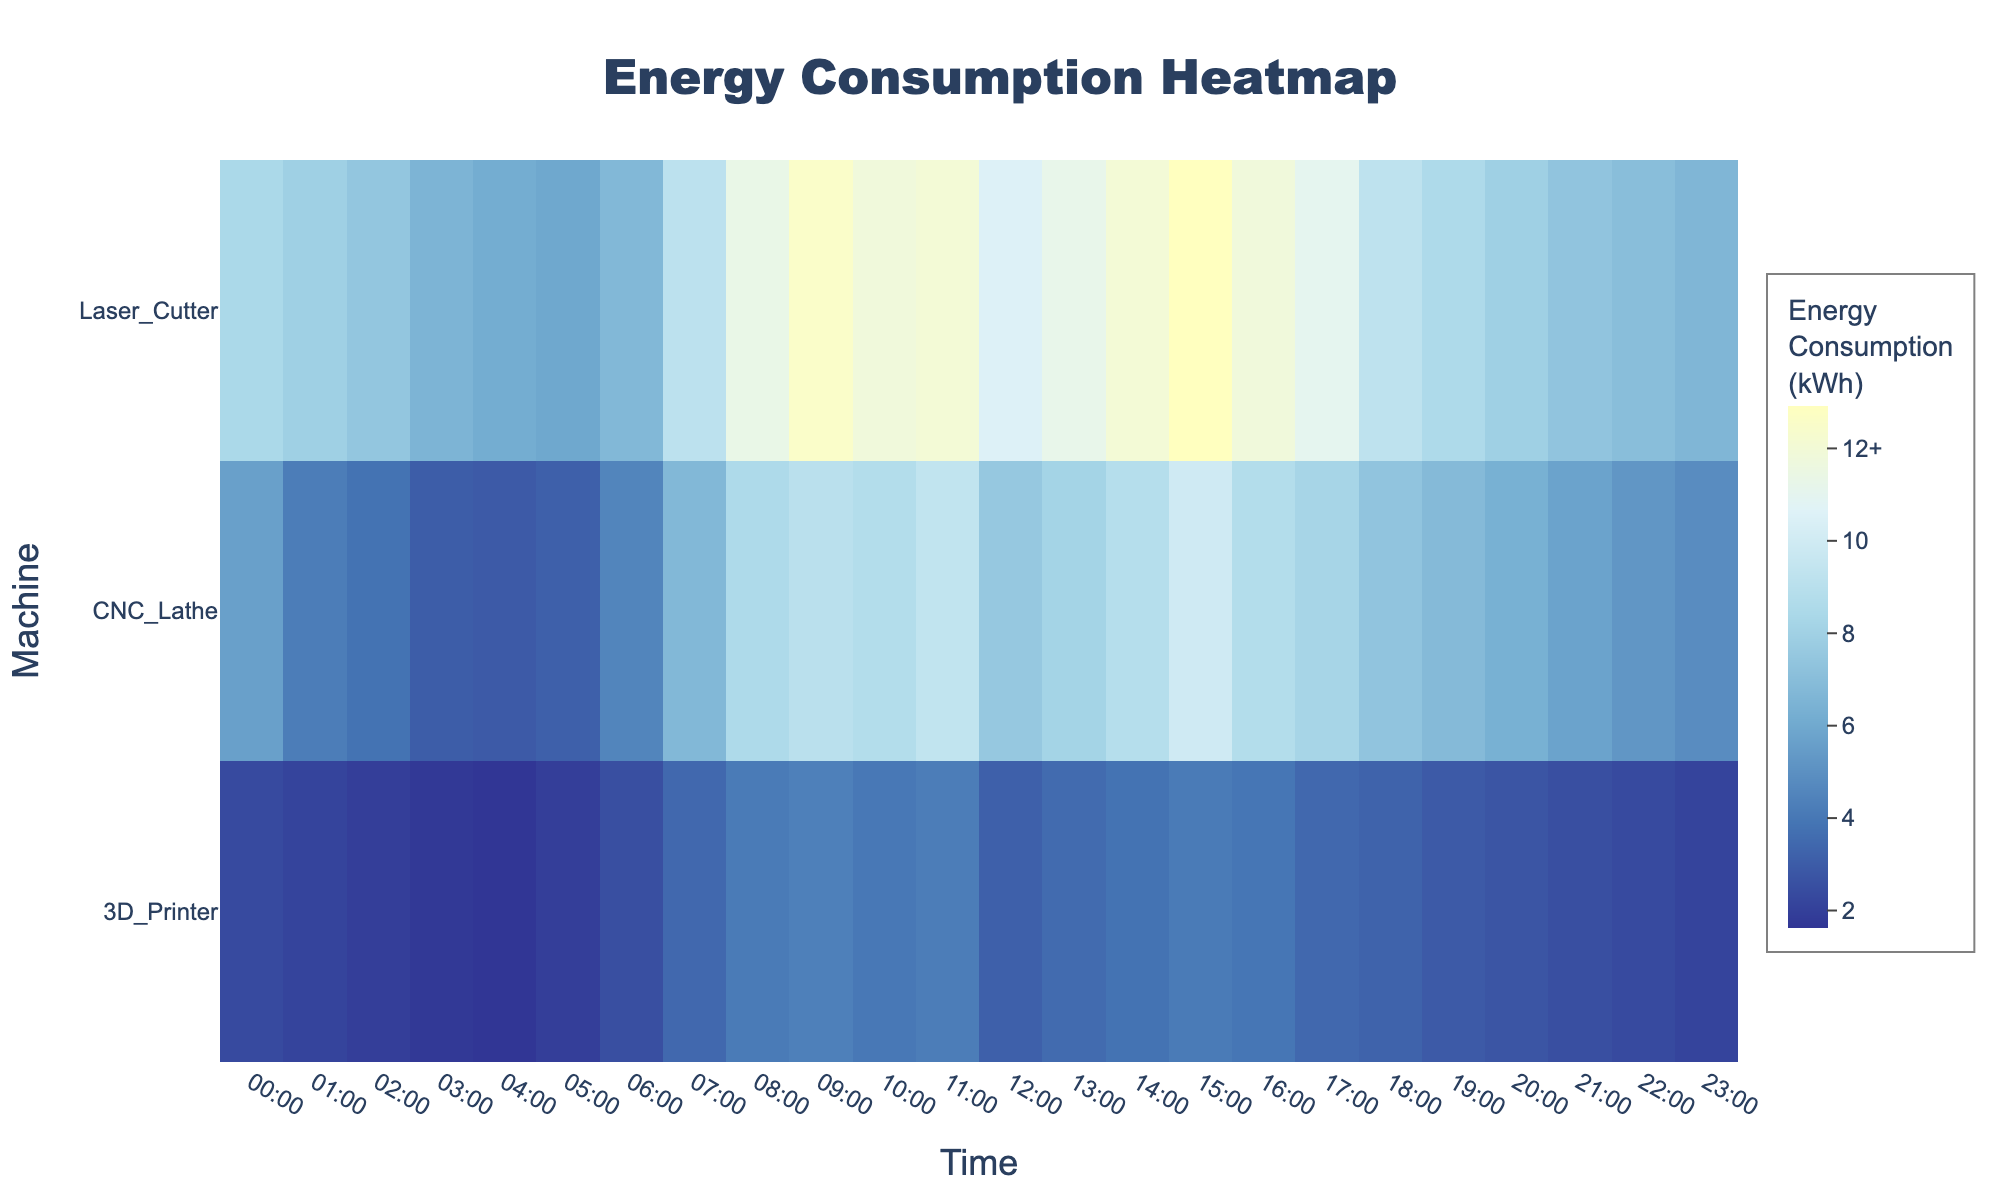How is the energy consumption of the CNC Lathe distributed throughout the day? To determine the distribution, look at the heatmap color intensity for the CNC Lathe row. Notice the color shift from blue hues in the early hours (low energy) to yellow hues during midday (high energy), and back to darker colors in the evening.
Answer: Low in early morning and evening, high during midday What machine consumes the most energy at 9:00? Compare the color intensities for all machines at 09:00. The Laser Cutter shows the brightest color indicating highest energy consumption at that time.
Answer: Laser Cutter What are the peak hours of energy consumption for the 3D Printer? Identify the brightest colors in the 3D Printer row. The peak hours are indicated by the color patterns around 08:00 to 11:00 and 15:00.
Answer: 08:00 to 11:00 and 15:00 Which machine has the lowest energy consumption at 3:00? Look at the color intensity for all machines at 03:00. The 3D Printer has the darkest hue, indicating the lowest energy consumption.
Answer: 3D Printer Compare the energy consumption of the CNC Lathe and Laser Cutter at 12:00. Examine the colors for both machines at 12:00. The Laser Cutter has a brighter color compared to the CNC Lathe, indicating higher energy consumption.
Answer: Laser Cutter consumes more During which hours does the CNC Lathe consume less than 5 kWh of energy? Analyze the heatmap colors for the CNC Lathe row and note the hours with colors signifying consumption below 5 kWh. This corresponds to the hours between 00:00 to 05:00 and 22:00 to 23:00.
Answer: 00:00 to 05:00 and 22:00 to 23:00 Calculate the average daily energy consumption for the Laser Cutter. First, sum up all values for the Laser Cutter, then divide by 24. The total is 244.6 kWh, yielding an average of 244.6 / 24 ≈ 10.2 kWh.
Answer: 10.2 kWh Which machine shows the most significant difference in energy consumption between peak and off-peak hours? Look for the machine with the most contrasting colors between peak (daytime) and off-peak (early morning/late evening) hours. The Laser Cutter demonstrates this with bright colors during the day and darker colors in off-peak hours.
Answer: Laser Cutter How does the energy consumption of the Laser Cutter compare to that of the 3D Printer at 15:00? Compare color intensities at 15:00. The Laser Cutter has a much brighter hue than the 3D Printer, indicating higher energy consumption.
Answer: Laser Cutter consumes more What is the highest recorded energy consumption on the heatmap, and which machine and time does it represent? Identify the highest color intensity on the heatmap. The brightest yellow appears at 15:00 for the Laser Cutter, representing the maximum consumption.
Answer: 12.9 kWh, Laser Cutter, 15:00 